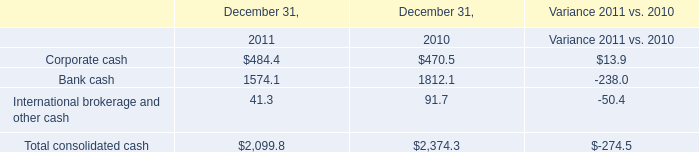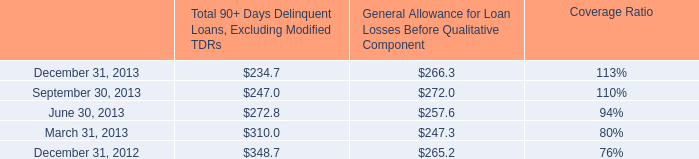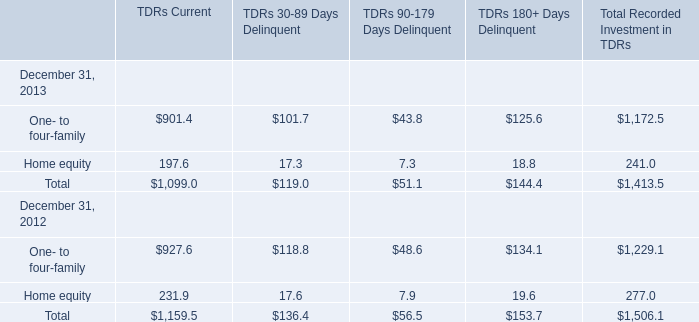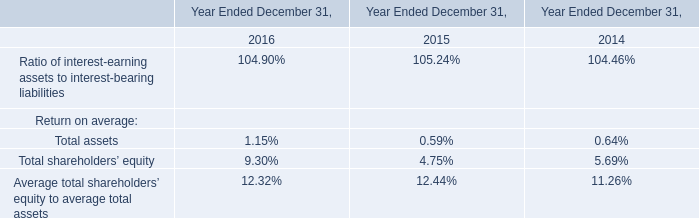What is the sum of the One- to four-family in the years where Home equity is greater than 200? 
Computations: (((927.6 + 118.8) + 48.6) + 134.1)
Answer: 1229.1. 